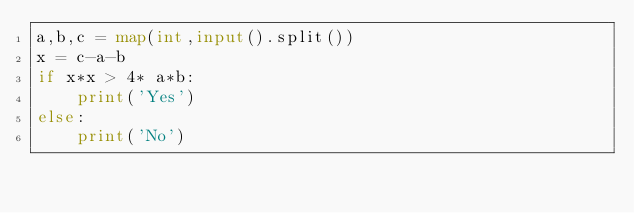Convert code to text. <code><loc_0><loc_0><loc_500><loc_500><_Python_>a,b,c = map(int,input().split())
x = c-a-b
if x*x > 4* a*b:
    print('Yes')
else:
    print('No')</code> 